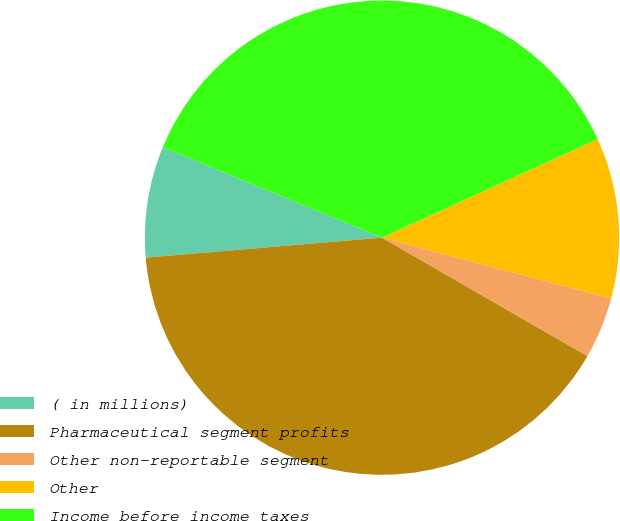<chart> <loc_0><loc_0><loc_500><loc_500><pie_chart><fcel>( in millions)<fcel>Pharmaceutical segment profits<fcel>Other non-reportable segment<fcel>Other<fcel>Income before income taxes<nl><fcel>7.57%<fcel>40.33%<fcel>4.19%<fcel>10.95%<fcel>36.95%<nl></chart> 